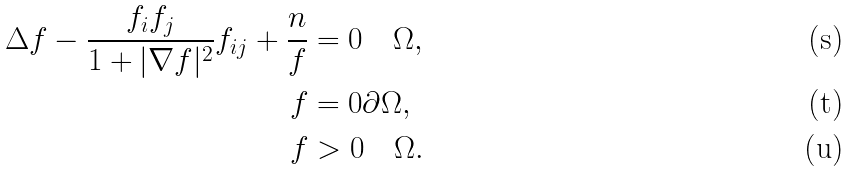<formula> <loc_0><loc_0><loc_500><loc_500>\Delta f - \frac { f _ { i } f _ { j } } { 1 + | \nabla f | ^ { 2 } } f _ { i j } + \frac { n } { f } & = 0 \quad \Omega , \\ f & = 0 \partial \Omega , \\ f & > 0 \quad \Omega .</formula> 